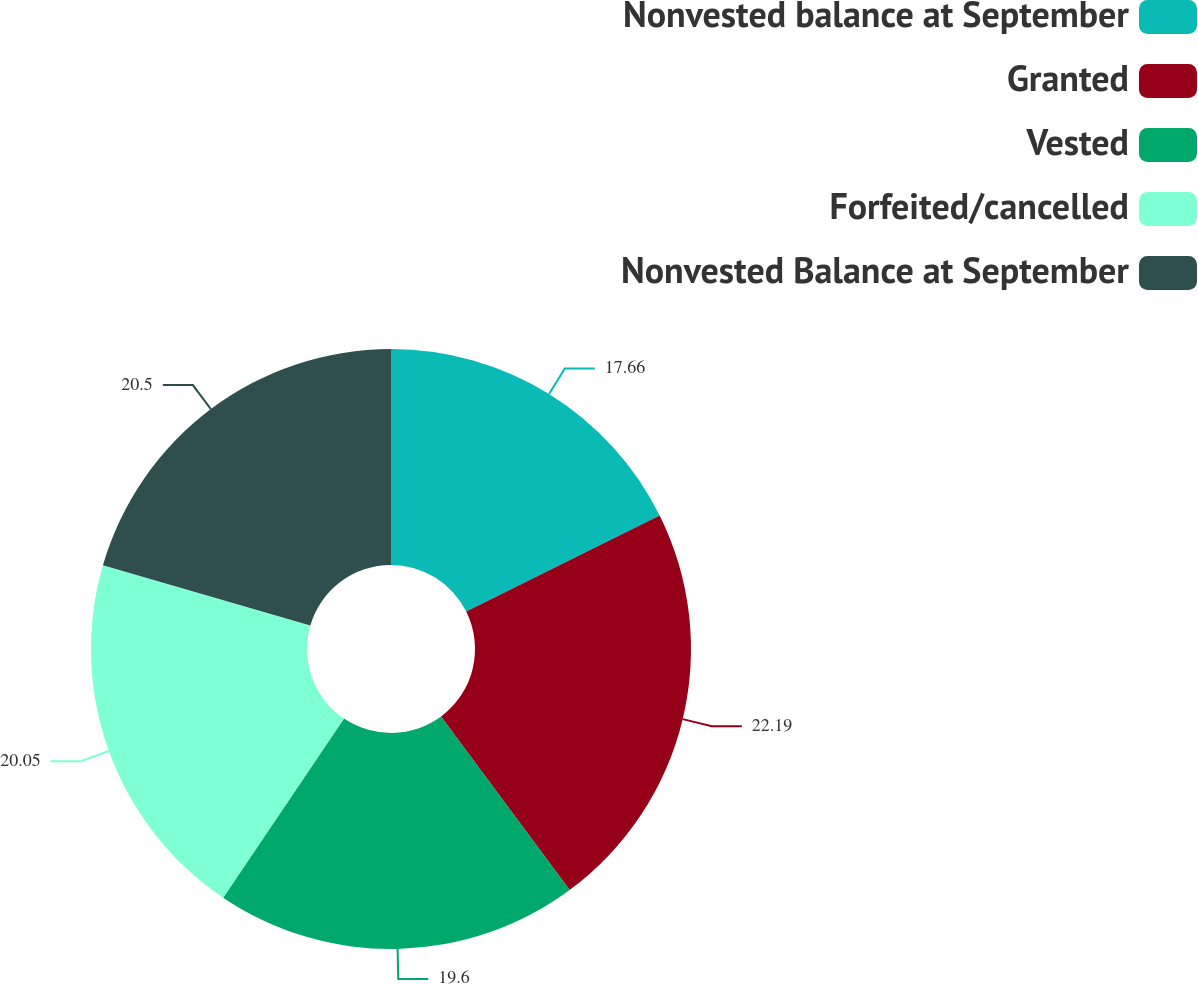<chart> <loc_0><loc_0><loc_500><loc_500><pie_chart><fcel>Nonvested balance at September<fcel>Granted<fcel>Vested<fcel>Forfeited/cancelled<fcel>Nonvested Balance at September<nl><fcel>17.66%<fcel>22.19%<fcel>19.6%<fcel>20.05%<fcel>20.5%<nl></chart> 